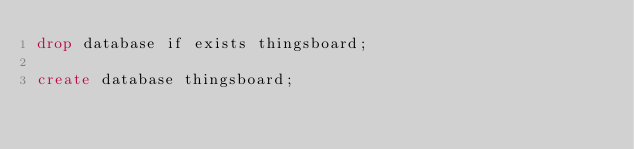Convert code to text. <code><loc_0><loc_0><loc_500><loc_500><_SQL_>drop database if exists thingsboard;

create database thingsboard;</code> 